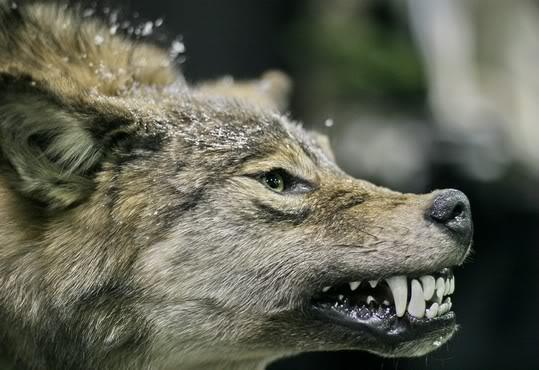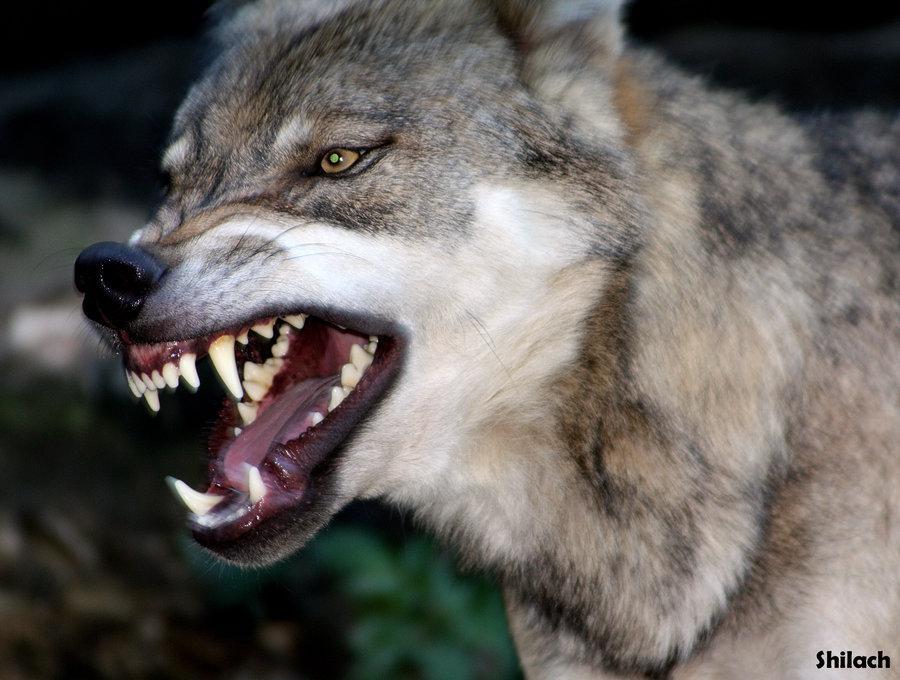The first image is the image on the left, the second image is the image on the right. Analyze the images presented: Is the assertion "wolves are standing with heads lowered toward the camera" valid? Answer yes or no. No. The first image is the image on the left, the second image is the image on the right. Considering the images on both sides, is "There is one wolf per image, and none of the wolves are showing their teeth." valid? Answer yes or no. No. 